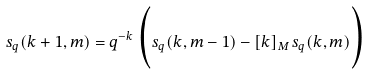<formula> <loc_0><loc_0><loc_500><loc_500>s _ { q } ( k + 1 , m ) = q ^ { - k } \, \Big { ( } s _ { q } ( k , m - 1 ) - [ k ] _ { M } \, s _ { q } ( k , m ) \Big { ) }</formula> 